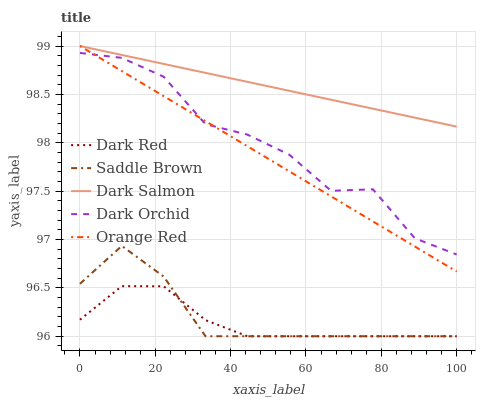Does Dark Red have the minimum area under the curve?
Answer yes or no. Yes. Does Dark Salmon have the maximum area under the curve?
Answer yes or no. Yes. Does Orange Red have the minimum area under the curve?
Answer yes or no. No. Does Orange Red have the maximum area under the curve?
Answer yes or no. No. Is Dark Salmon the smoothest?
Answer yes or no. Yes. Is Dark Orchid the roughest?
Answer yes or no. Yes. Is Orange Red the smoothest?
Answer yes or no. No. Is Orange Red the roughest?
Answer yes or no. No. Does Dark Red have the lowest value?
Answer yes or no. Yes. Does Orange Red have the lowest value?
Answer yes or no. No. Does Dark Salmon have the highest value?
Answer yes or no. Yes. Does Saddle Brown have the highest value?
Answer yes or no. No. Is Dark Red less than Dark Salmon?
Answer yes or no. Yes. Is Dark Orchid greater than Saddle Brown?
Answer yes or no. Yes. Does Dark Orchid intersect Orange Red?
Answer yes or no. Yes. Is Dark Orchid less than Orange Red?
Answer yes or no. No. Is Dark Orchid greater than Orange Red?
Answer yes or no. No. Does Dark Red intersect Dark Salmon?
Answer yes or no. No. 